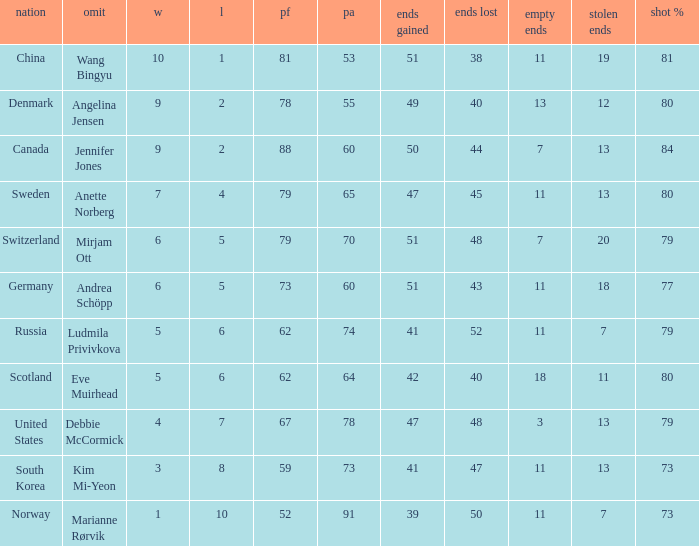What is Norway's least ends lost? 50.0. 